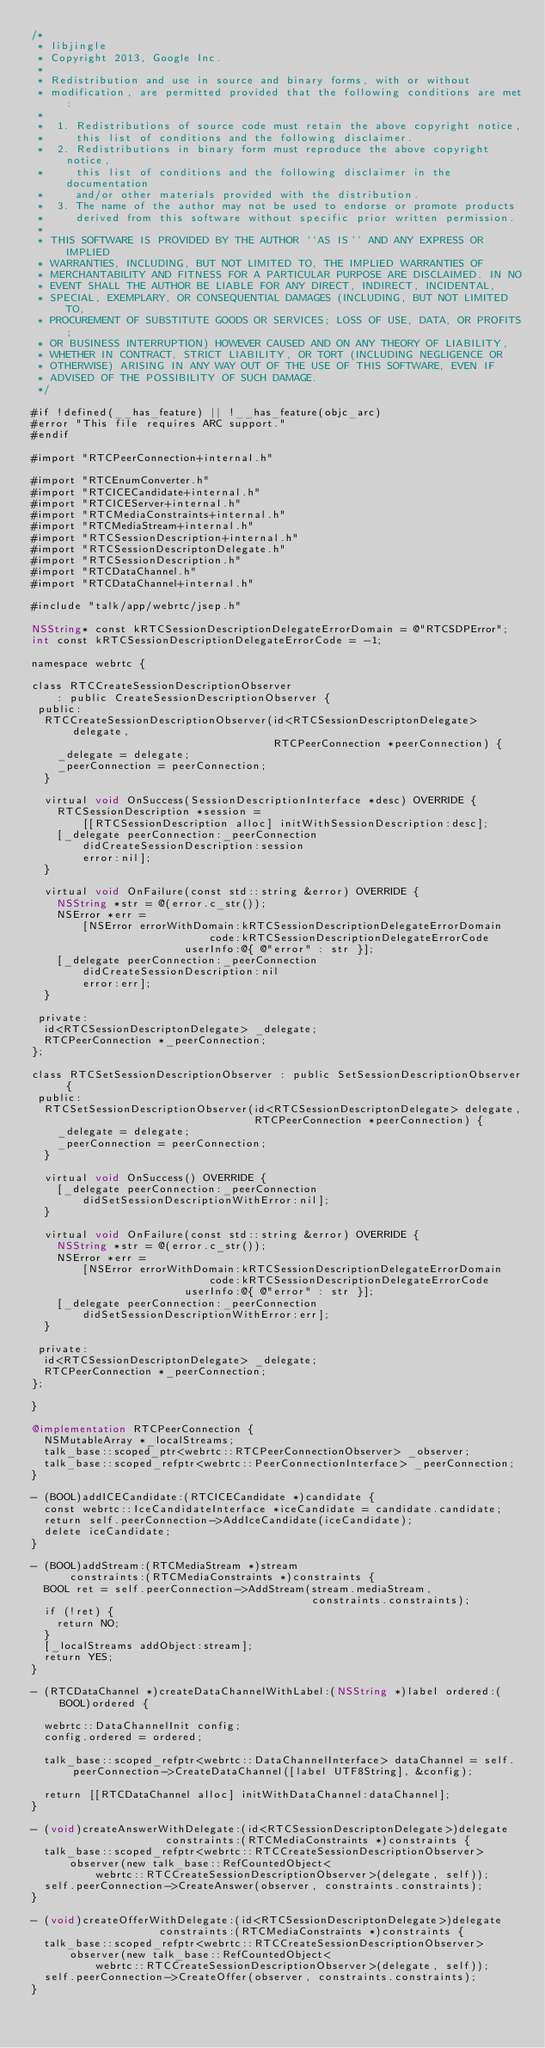<code> <loc_0><loc_0><loc_500><loc_500><_ObjectiveC_>/*
 * libjingle
 * Copyright 2013, Google Inc.
 *
 * Redistribution and use in source and binary forms, with or without
 * modification, are permitted provided that the following conditions are met:
 *
 *  1. Redistributions of source code must retain the above copyright notice,
 *     this list of conditions and the following disclaimer.
 *  2. Redistributions in binary form must reproduce the above copyright notice,
 *     this list of conditions and the following disclaimer in the documentation
 *     and/or other materials provided with the distribution.
 *  3. The name of the author may not be used to endorse or promote products
 *     derived from this software without specific prior written permission.
 *
 * THIS SOFTWARE IS PROVIDED BY THE AUTHOR ``AS IS'' AND ANY EXPRESS OR IMPLIED
 * WARRANTIES, INCLUDING, BUT NOT LIMITED TO, THE IMPLIED WARRANTIES OF
 * MERCHANTABILITY AND FITNESS FOR A PARTICULAR PURPOSE ARE DISCLAIMED. IN NO
 * EVENT SHALL THE AUTHOR BE LIABLE FOR ANY DIRECT, INDIRECT, INCIDENTAL,
 * SPECIAL, EXEMPLARY, OR CONSEQUENTIAL DAMAGES (INCLUDING, BUT NOT LIMITED TO,
 * PROCUREMENT OF SUBSTITUTE GOODS OR SERVICES; LOSS OF USE, DATA, OR PROFITS;
 * OR BUSINESS INTERRUPTION) HOWEVER CAUSED AND ON ANY THEORY OF LIABILITY,
 * WHETHER IN CONTRACT, STRICT LIABILITY, OR TORT (INCLUDING NEGLIGENCE OR
 * OTHERWISE) ARISING IN ANY WAY OUT OF THE USE OF THIS SOFTWARE, EVEN IF
 * ADVISED OF THE POSSIBILITY OF SUCH DAMAGE.
 */

#if !defined(__has_feature) || !__has_feature(objc_arc)
#error "This file requires ARC support."
#endif

#import "RTCPeerConnection+internal.h"

#import "RTCEnumConverter.h"
#import "RTCICECandidate+internal.h"
#import "RTCICEServer+internal.h"
#import "RTCMediaConstraints+internal.h"
#import "RTCMediaStream+internal.h"
#import "RTCSessionDescription+internal.h"
#import "RTCSessionDescriptonDelegate.h"
#import "RTCSessionDescription.h"
#import "RTCDataChannel.h"
#import "RTCDataChannel+internal.h"

#include "talk/app/webrtc/jsep.h"

NSString* const kRTCSessionDescriptionDelegateErrorDomain = @"RTCSDPError";
int const kRTCSessionDescriptionDelegateErrorCode = -1;

namespace webrtc {

class RTCCreateSessionDescriptionObserver
    : public CreateSessionDescriptionObserver {
 public:
  RTCCreateSessionDescriptionObserver(id<RTCSessionDescriptonDelegate> delegate,
                                      RTCPeerConnection *peerConnection) {
    _delegate = delegate;
    _peerConnection = peerConnection;
  }

  virtual void OnSuccess(SessionDescriptionInterface *desc) OVERRIDE {
    RTCSessionDescription *session =
        [[RTCSessionDescription alloc] initWithSessionDescription:desc];
    [_delegate peerConnection:_peerConnection
        didCreateSessionDescription:session
        error:nil];
  }

  virtual void OnFailure(const std::string &error) OVERRIDE {
    NSString *str = @(error.c_str());
    NSError *err =
        [NSError errorWithDomain:kRTCSessionDescriptionDelegateErrorDomain
                            code:kRTCSessionDescriptionDelegateErrorCode
                        userInfo:@{ @"error" : str }];
    [_delegate peerConnection:_peerConnection
        didCreateSessionDescription:nil
        error:err];
  }

 private:
  id<RTCSessionDescriptonDelegate> _delegate;
  RTCPeerConnection *_peerConnection;
};

class RTCSetSessionDescriptionObserver : public SetSessionDescriptionObserver {
 public:
  RTCSetSessionDescriptionObserver(id<RTCSessionDescriptonDelegate> delegate,
                                   RTCPeerConnection *peerConnection) {
    _delegate = delegate;
    _peerConnection = peerConnection;
  }

  virtual void OnSuccess() OVERRIDE {
    [_delegate peerConnection:_peerConnection
        didSetSessionDescriptionWithError:nil];
  }

  virtual void OnFailure(const std::string &error) OVERRIDE {
    NSString *str = @(error.c_str());
    NSError *err =
        [NSError errorWithDomain:kRTCSessionDescriptionDelegateErrorDomain
                            code:kRTCSessionDescriptionDelegateErrorCode
                        userInfo:@{ @"error" : str }];
    [_delegate peerConnection:_peerConnection
        didSetSessionDescriptionWithError:err];
  }

 private:
  id<RTCSessionDescriptonDelegate> _delegate;
  RTCPeerConnection *_peerConnection;
};

}

@implementation RTCPeerConnection {
  NSMutableArray *_localStreams;
  talk_base::scoped_ptr<webrtc::RTCPeerConnectionObserver> _observer;
  talk_base::scoped_refptr<webrtc::PeerConnectionInterface> _peerConnection;
}

- (BOOL)addICECandidate:(RTCICECandidate *)candidate {
  const webrtc::IceCandidateInterface *iceCandidate = candidate.candidate;
  return self.peerConnection->AddIceCandidate(iceCandidate);
  delete iceCandidate;
}

- (BOOL)addStream:(RTCMediaStream *)stream
      constraints:(RTCMediaConstraints *)constraints {
  BOOL ret = self.peerConnection->AddStream(stream.mediaStream,
                                            constraints.constraints);
  if (!ret) {
    return NO;
  }
  [_localStreams addObject:stream];
  return YES;
}

- (RTCDataChannel *)createDataChannelWithLabel:(NSString *)label ordered:(BOOL)ordered {
  
  webrtc::DataChannelInit config;
  config.ordered = ordered;
  
  talk_base::scoped_refptr<webrtc::DataChannelInterface> dataChannel = self.peerConnection->CreateDataChannel([label UTF8String], &config);
  
  return [[RTCDataChannel alloc] initWithDataChannel:dataChannel];
}

- (void)createAnswerWithDelegate:(id<RTCSessionDescriptonDelegate>)delegate
                     constraints:(RTCMediaConstraints *)constraints {
  talk_base::scoped_refptr<webrtc::RTCCreateSessionDescriptionObserver>
      observer(new talk_base::RefCountedObject<
          webrtc::RTCCreateSessionDescriptionObserver>(delegate, self));
  self.peerConnection->CreateAnswer(observer, constraints.constraints);
}

- (void)createOfferWithDelegate:(id<RTCSessionDescriptonDelegate>)delegate
                    constraints:(RTCMediaConstraints *)constraints {
  talk_base::scoped_refptr<webrtc::RTCCreateSessionDescriptionObserver>
      observer(new talk_base::RefCountedObject<
          webrtc::RTCCreateSessionDescriptionObserver>(delegate, self));
  self.peerConnection->CreateOffer(observer, constraints.constraints);
}
</code> 